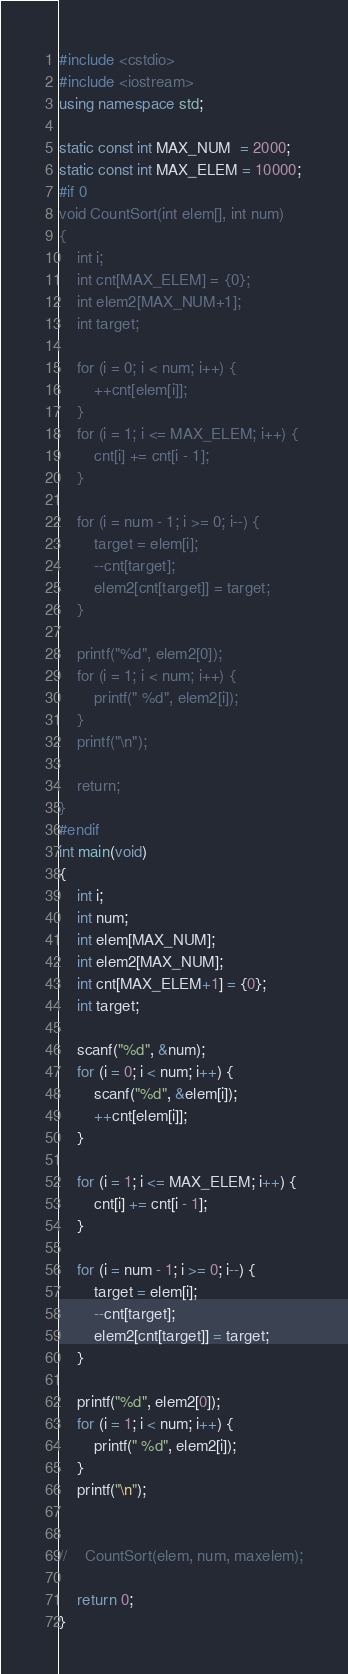Convert code to text. <code><loc_0><loc_0><loc_500><loc_500><_C++_>#include <cstdio>
#include <iostream>
using namespace std;

static const int MAX_NUM  = 2000;
static const int MAX_ELEM = 10000;
#if 0
void CountSort(int elem[], int num)
{
    int i;
    int cnt[MAX_ELEM] = {0};
    int elem2[MAX_NUM+1];
    int target;

    for (i = 0; i < num; i++) {
        ++cnt[elem[i]];
    }
    for (i = 1; i <= MAX_ELEM; i++) {
        cnt[i] += cnt[i - 1];
    }

    for (i = num - 1; i >= 0; i--) {
        target = elem[i];
        --cnt[target];
        elem2[cnt[target]] = target;
    }

    printf("%d", elem2[0]);
    for (i = 1; i < num; i++) {
        printf(" %d", elem2[i]);
    }
    printf("\n");

    return;
}
#endif
int main(void)
{
    int i;
    int num;
    int elem[MAX_NUM];
    int elem2[MAX_NUM];
    int cnt[MAX_ELEM+1] = {0};
    int target;

    scanf("%d", &num);
    for (i = 0; i < num; i++) {
        scanf("%d", &elem[i]);
        ++cnt[elem[i]];
    }

    for (i = 1; i <= MAX_ELEM; i++) {
        cnt[i] += cnt[i - 1];
    }

    for (i = num - 1; i >= 0; i--) {
        target = elem[i];
        --cnt[target];
        elem2[cnt[target]] = target;
    }

    printf("%d", elem2[0]);
    for (i = 1; i < num; i++) {
        printf(" %d", elem2[i]);
    }
    printf("\n");


//    CountSort(elem, num, maxelem);

    return 0;
}</code> 